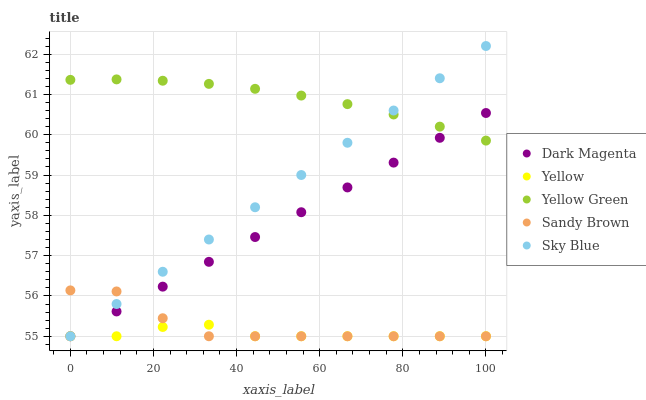Does Yellow have the minimum area under the curve?
Answer yes or no. Yes. Does Yellow Green have the maximum area under the curve?
Answer yes or no. Yes. Does Sandy Brown have the minimum area under the curve?
Answer yes or no. No. Does Sandy Brown have the maximum area under the curve?
Answer yes or no. No. Is Sky Blue the smoothest?
Answer yes or no. Yes. Is Sandy Brown the roughest?
Answer yes or no. Yes. Is Dark Magenta the smoothest?
Answer yes or no. No. Is Dark Magenta the roughest?
Answer yes or no. No. Does Sky Blue have the lowest value?
Answer yes or no. Yes. Does Yellow Green have the lowest value?
Answer yes or no. No. Does Sky Blue have the highest value?
Answer yes or no. Yes. Does Sandy Brown have the highest value?
Answer yes or no. No. Is Yellow less than Yellow Green?
Answer yes or no. Yes. Is Yellow Green greater than Yellow?
Answer yes or no. Yes. Does Sky Blue intersect Dark Magenta?
Answer yes or no. Yes. Is Sky Blue less than Dark Magenta?
Answer yes or no. No. Is Sky Blue greater than Dark Magenta?
Answer yes or no. No. Does Yellow intersect Yellow Green?
Answer yes or no. No. 